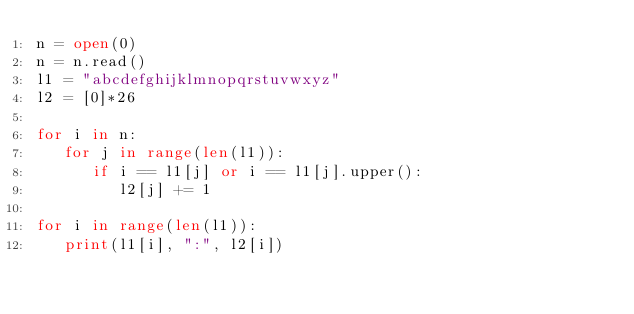Convert code to text. <code><loc_0><loc_0><loc_500><loc_500><_Python_>n = open(0)
n = n.read()
l1 = "abcdefghijklmnopqrstuvwxyz"
l2 = [0]*26

for i in n:
   for j in range(len(l1)):
      if i == l1[j] or i == l1[j].upper():
         l2[j] += 1

for i in range(len(l1)):
   print(l1[i], ":", l2[i])


</code> 